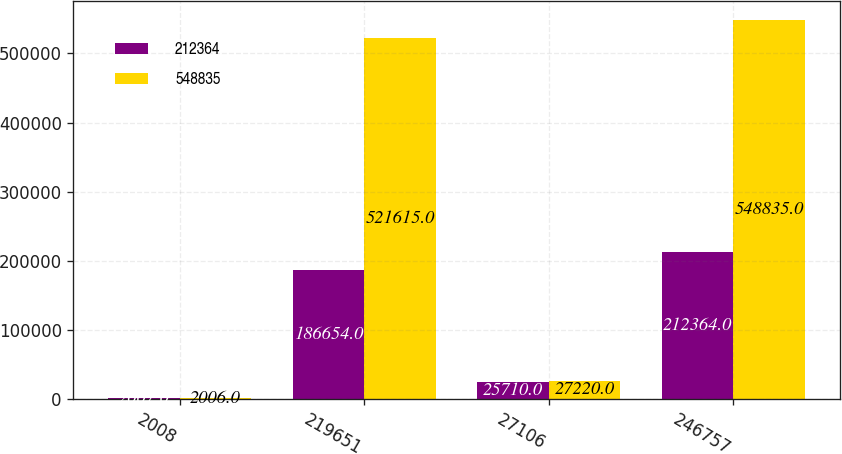Convert chart to OTSL. <chart><loc_0><loc_0><loc_500><loc_500><stacked_bar_chart><ecel><fcel>2008<fcel>219651<fcel>27106<fcel>246757<nl><fcel>212364<fcel>2007<fcel>186654<fcel>25710<fcel>212364<nl><fcel>548835<fcel>2006<fcel>521615<fcel>27220<fcel>548835<nl></chart> 